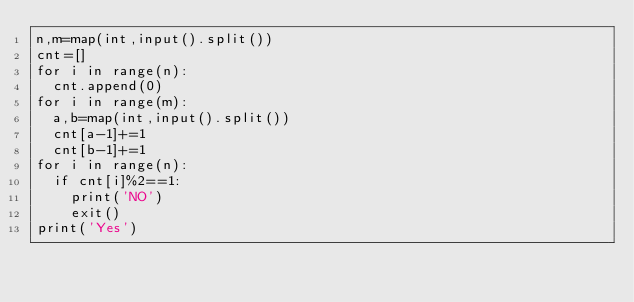<code> <loc_0><loc_0><loc_500><loc_500><_Python_>n,m=map(int,input().split())
cnt=[]
for i in range(n):
  cnt.append(0)
for i in range(m):
  a,b=map(int,input().split())
  cnt[a-1]+=1
  cnt[b-1]+=1
for i in range(n):
  if cnt[i]%2==1:
    print('NO')
    exit()
print('Yes')</code> 